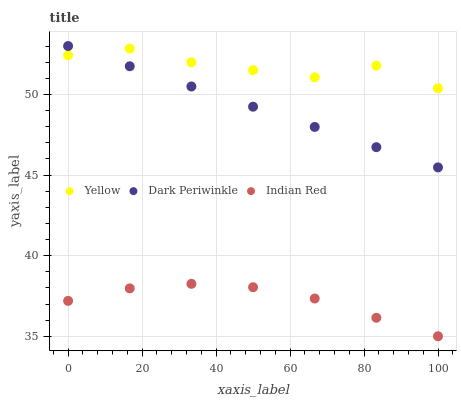Does Indian Red have the minimum area under the curve?
Answer yes or no. Yes. Does Yellow have the maximum area under the curve?
Answer yes or no. Yes. Does Dark Periwinkle have the minimum area under the curve?
Answer yes or no. No. Does Dark Periwinkle have the maximum area under the curve?
Answer yes or no. No. Is Dark Periwinkle the smoothest?
Answer yes or no. Yes. Is Yellow the roughest?
Answer yes or no. Yes. Is Yellow the smoothest?
Answer yes or no. No. Is Dark Periwinkle the roughest?
Answer yes or no. No. Does Indian Red have the lowest value?
Answer yes or no. Yes. Does Dark Periwinkle have the lowest value?
Answer yes or no. No. Does Dark Periwinkle have the highest value?
Answer yes or no. Yes. Does Yellow have the highest value?
Answer yes or no. No. Is Indian Red less than Dark Periwinkle?
Answer yes or no. Yes. Is Dark Periwinkle greater than Indian Red?
Answer yes or no. Yes. Does Yellow intersect Dark Periwinkle?
Answer yes or no. Yes. Is Yellow less than Dark Periwinkle?
Answer yes or no. No. Is Yellow greater than Dark Periwinkle?
Answer yes or no. No. Does Indian Red intersect Dark Periwinkle?
Answer yes or no. No. 